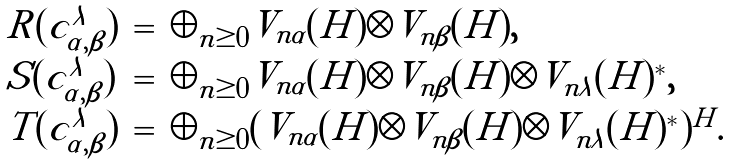Convert formula to latex. <formula><loc_0><loc_0><loc_500><loc_500>\begin{array} { l c l } R ( c _ { \alpha , \beta } ^ { \lambda } ) & = & \oplus _ { n \geq 0 } V _ { n \alpha } ( H ) \otimes V _ { n \beta } ( H ) , \\ S ( c _ { \alpha , \beta } ^ { \lambda } ) & = & \oplus _ { n \geq 0 } V _ { n \alpha } ( H ) \otimes V _ { n \beta } ( H ) \otimes V _ { n \lambda } ( H ) ^ { * } , \\ T ( c _ { \alpha , \beta } ^ { \lambda } ) & = & \oplus _ { n \geq 0 } ( V _ { n \alpha } ( H ) \otimes V _ { n \beta } ( H ) \otimes V _ { n \lambda } ( H ) ^ { * } ) ^ { H } . \end{array}</formula> 